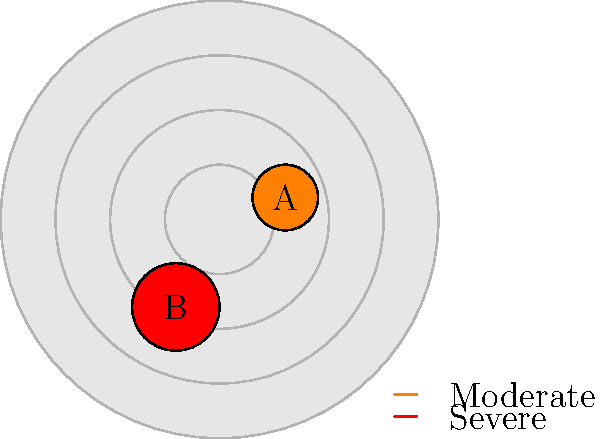Based on the weather radar image, which storm cell (A or B) should you be more concerned about for your son's safety, and why? To interpret the weather radar image and determine storm severity, follow these steps:

1. Identify the storm cells: There are two visible storm cells, labeled A and B.

2. Analyze the colors:
   - Storm A is colored orange, which typically indicates moderate intensity.
   - Storm B is colored red, which usually represents severe intensity.

3. Compare the sizes:
   - Storm A is smaller in diameter.
   - Storm B is larger, covering a wider area.

4. Consider the implications:
   - Larger, more intense storms (like B) are generally more dangerous.
   - They often produce stronger winds, heavier rainfall, and possibly hail or tornadoes.

5. Relate to safety concerns:
   - As a concerned mother, you would be more worried about the larger, red-colored storm (B).
   - It poses a greater threat to your son's safety due to its higher intensity and larger size.

Therefore, Storm B should be of greater concern for your son's safety. It's more severe and covers a larger area, increasing the potential for dangerous weather conditions.
Answer: Storm B, due to its red color (indicating higher intensity) and larger size. 